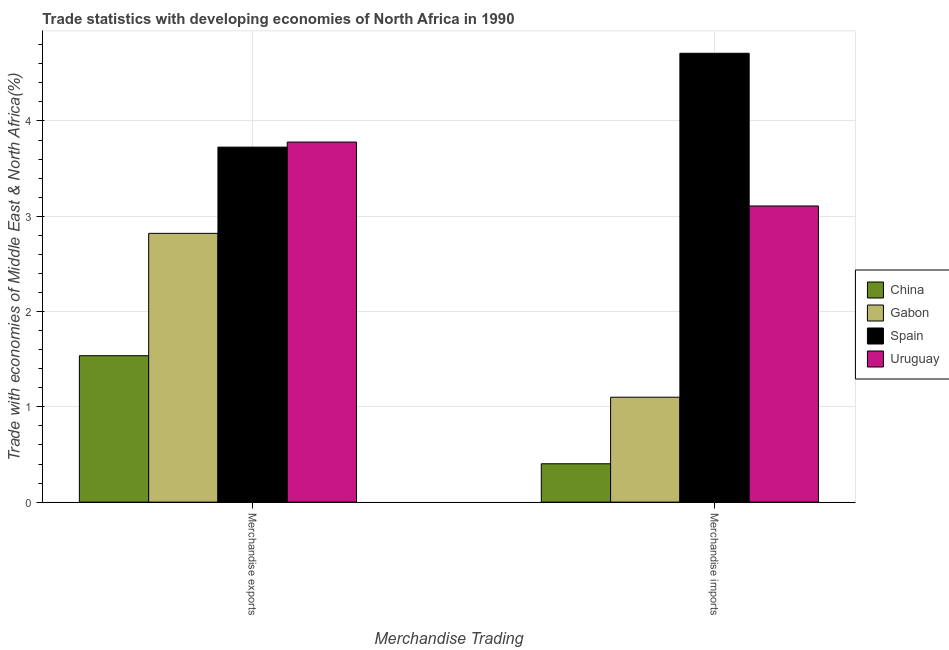How many different coloured bars are there?
Provide a succinct answer. 4. How many groups of bars are there?
Your answer should be very brief. 2. Are the number of bars per tick equal to the number of legend labels?
Keep it short and to the point. Yes. How many bars are there on the 2nd tick from the left?
Provide a succinct answer. 4. How many bars are there on the 2nd tick from the right?
Give a very brief answer. 4. What is the merchandise imports in Spain?
Your answer should be very brief. 4.71. Across all countries, what is the maximum merchandise imports?
Provide a succinct answer. 4.71. Across all countries, what is the minimum merchandise exports?
Make the answer very short. 1.54. In which country was the merchandise exports maximum?
Offer a terse response. Uruguay. In which country was the merchandise imports minimum?
Your response must be concise. China. What is the total merchandise imports in the graph?
Make the answer very short. 9.32. What is the difference between the merchandise exports in China and that in Spain?
Your answer should be compact. -2.19. What is the difference between the merchandise exports in China and the merchandise imports in Spain?
Your answer should be very brief. -3.17. What is the average merchandise imports per country?
Your response must be concise. 2.33. What is the difference between the merchandise imports and merchandise exports in Spain?
Keep it short and to the point. 0.98. What is the ratio of the merchandise imports in Uruguay to that in Gabon?
Your answer should be compact. 2.82. What does the 3rd bar from the right in Merchandise exports represents?
Provide a short and direct response. Gabon. How many bars are there?
Ensure brevity in your answer.  8. Are all the bars in the graph horizontal?
Provide a succinct answer. No. Does the graph contain any zero values?
Give a very brief answer. No. Where does the legend appear in the graph?
Provide a succinct answer. Center right. What is the title of the graph?
Your answer should be very brief. Trade statistics with developing economies of North Africa in 1990. Does "High income: OECD" appear as one of the legend labels in the graph?
Offer a terse response. No. What is the label or title of the X-axis?
Provide a short and direct response. Merchandise Trading. What is the label or title of the Y-axis?
Your response must be concise. Trade with economies of Middle East & North Africa(%). What is the Trade with economies of Middle East & North Africa(%) in China in Merchandise exports?
Your response must be concise. 1.54. What is the Trade with economies of Middle East & North Africa(%) in Gabon in Merchandise exports?
Your answer should be compact. 2.82. What is the Trade with economies of Middle East & North Africa(%) in Spain in Merchandise exports?
Keep it short and to the point. 3.73. What is the Trade with economies of Middle East & North Africa(%) in Uruguay in Merchandise exports?
Ensure brevity in your answer.  3.78. What is the Trade with economies of Middle East & North Africa(%) in China in Merchandise imports?
Your answer should be compact. 0.4. What is the Trade with economies of Middle East & North Africa(%) of Gabon in Merchandise imports?
Offer a terse response. 1.1. What is the Trade with economies of Middle East & North Africa(%) in Spain in Merchandise imports?
Make the answer very short. 4.71. What is the Trade with economies of Middle East & North Africa(%) in Uruguay in Merchandise imports?
Your response must be concise. 3.11. Across all Merchandise Trading, what is the maximum Trade with economies of Middle East & North Africa(%) in China?
Give a very brief answer. 1.54. Across all Merchandise Trading, what is the maximum Trade with economies of Middle East & North Africa(%) of Gabon?
Your answer should be very brief. 2.82. Across all Merchandise Trading, what is the maximum Trade with economies of Middle East & North Africa(%) of Spain?
Make the answer very short. 4.71. Across all Merchandise Trading, what is the maximum Trade with economies of Middle East & North Africa(%) in Uruguay?
Ensure brevity in your answer.  3.78. Across all Merchandise Trading, what is the minimum Trade with economies of Middle East & North Africa(%) of China?
Offer a terse response. 0.4. Across all Merchandise Trading, what is the minimum Trade with economies of Middle East & North Africa(%) of Gabon?
Offer a very short reply. 1.1. Across all Merchandise Trading, what is the minimum Trade with economies of Middle East & North Africa(%) in Spain?
Keep it short and to the point. 3.73. Across all Merchandise Trading, what is the minimum Trade with economies of Middle East & North Africa(%) in Uruguay?
Ensure brevity in your answer.  3.11. What is the total Trade with economies of Middle East & North Africa(%) in China in the graph?
Ensure brevity in your answer.  1.94. What is the total Trade with economies of Middle East & North Africa(%) of Gabon in the graph?
Offer a terse response. 3.92. What is the total Trade with economies of Middle East & North Africa(%) in Spain in the graph?
Offer a very short reply. 8.44. What is the total Trade with economies of Middle East & North Africa(%) of Uruguay in the graph?
Your answer should be very brief. 6.89. What is the difference between the Trade with economies of Middle East & North Africa(%) in China in Merchandise exports and that in Merchandise imports?
Make the answer very short. 1.13. What is the difference between the Trade with economies of Middle East & North Africa(%) in Gabon in Merchandise exports and that in Merchandise imports?
Offer a terse response. 1.72. What is the difference between the Trade with economies of Middle East & North Africa(%) of Spain in Merchandise exports and that in Merchandise imports?
Provide a short and direct response. -0.98. What is the difference between the Trade with economies of Middle East & North Africa(%) in Uruguay in Merchandise exports and that in Merchandise imports?
Give a very brief answer. 0.67. What is the difference between the Trade with economies of Middle East & North Africa(%) in China in Merchandise exports and the Trade with economies of Middle East & North Africa(%) in Gabon in Merchandise imports?
Keep it short and to the point. 0.44. What is the difference between the Trade with economies of Middle East & North Africa(%) in China in Merchandise exports and the Trade with economies of Middle East & North Africa(%) in Spain in Merchandise imports?
Your answer should be compact. -3.17. What is the difference between the Trade with economies of Middle East & North Africa(%) of China in Merchandise exports and the Trade with economies of Middle East & North Africa(%) of Uruguay in Merchandise imports?
Provide a succinct answer. -1.57. What is the difference between the Trade with economies of Middle East & North Africa(%) of Gabon in Merchandise exports and the Trade with economies of Middle East & North Africa(%) of Spain in Merchandise imports?
Your answer should be compact. -1.89. What is the difference between the Trade with economies of Middle East & North Africa(%) of Gabon in Merchandise exports and the Trade with economies of Middle East & North Africa(%) of Uruguay in Merchandise imports?
Offer a very short reply. -0.29. What is the difference between the Trade with economies of Middle East & North Africa(%) of Spain in Merchandise exports and the Trade with economies of Middle East & North Africa(%) of Uruguay in Merchandise imports?
Your answer should be very brief. 0.62. What is the average Trade with economies of Middle East & North Africa(%) in China per Merchandise Trading?
Provide a succinct answer. 0.97. What is the average Trade with economies of Middle East & North Africa(%) of Gabon per Merchandise Trading?
Your answer should be compact. 1.96. What is the average Trade with economies of Middle East & North Africa(%) of Spain per Merchandise Trading?
Make the answer very short. 4.22. What is the average Trade with economies of Middle East & North Africa(%) of Uruguay per Merchandise Trading?
Give a very brief answer. 3.44. What is the difference between the Trade with economies of Middle East & North Africa(%) in China and Trade with economies of Middle East & North Africa(%) in Gabon in Merchandise exports?
Ensure brevity in your answer.  -1.28. What is the difference between the Trade with economies of Middle East & North Africa(%) in China and Trade with economies of Middle East & North Africa(%) in Spain in Merchandise exports?
Provide a short and direct response. -2.19. What is the difference between the Trade with economies of Middle East & North Africa(%) of China and Trade with economies of Middle East & North Africa(%) of Uruguay in Merchandise exports?
Offer a very short reply. -2.24. What is the difference between the Trade with economies of Middle East & North Africa(%) in Gabon and Trade with economies of Middle East & North Africa(%) in Spain in Merchandise exports?
Offer a very short reply. -0.91. What is the difference between the Trade with economies of Middle East & North Africa(%) in Gabon and Trade with economies of Middle East & North Africa(%) in Uruguay in Merchandise exports?
Make the answer very short. -0.96. What is the difference between the Trade with economies of Middle East & North Africa(%) in Spain and Trade with economies of Middle East & North Africa(%) in Uruguay in Merchandise exports?
Give a very brief answer. -0.05. What is the difference between the Trade with economies of Middle East & North Africa(%) in China and Trade with economies of Middle East & North Africa(%) in Gabon in Merchandise imports?
Provide a short and direct response. -0.7. What is the difference between the Trade with economies of Middle East & North Africa(%) of China and Trade with economies of Middle East & North Africa(%) of Spain in Merchandise imports?
Offer a very short reply. -4.31. What is the difference between the Trade with economies of Middle East & North Africa(%) of China and Trade with economies of Middle East & North Africa(%) of Uruguay in Merchandise imports?
Offer a very short reply. -2.71. What is the difference between the Trade with economies of Middle East & North Africa(%) in Gabon and Trade with economies of Middle East & North Africa(%) in Spain in Merchandise imports?
Offer a terse response. -3.61. What is the difference between the Trade with economies of Middle East & North Africa(%) of Gabon and Trade with economies of Middle East & North Africa(%) of Uruguay in Merchandise imports?
Offer a terse response. -2.01. What is the difference between the Trade with economies of Middle East & North Africa(%) of Spain and Trade with economies of Middle East & North Africa(%) of Uruguay in Merchandise imports?
Your answer should be compact. 1.6. What is the ratio of the Trade with economies of Middle East & North Africa(%) in China in Merchandise exports to that in Merchandise imports?
Your answer should be compact. 3.82. What is the ratio of the Trade with economies of Middle East & North Africa(%) of Gabon in Merchandise exports to that in Merchandise imports?
Your response must be concise. 2.56. What is the ratio of the Trade with economies of Middle East & North Africa(%) of Spain in Merchandise exports to that in Merchandise imports?
Your response must be concise. 0.79. What is the ratio of the Trade with economies of Middle East & North Africa(%) of Uruguay in Merchandise exports to that in Merchandise imports?
Keep it short and to the point. 1.22. What is the difference between the highest and the second highest Trade with economies of Middle East & North Africa(%) of China?
Offer a very short reply. 1.13. What is the difference between the highest and the second highest Trade with economies of Middle East & North Africa(%) in Gabon?
Your response must be concise. 1.72. What is the difference between the highest and the second highest Trade with economies of Middle East & North Africa(%) of Spain?
Provide a short and direct response. 0.98. What is the difference between the highest and the second highest Trade with economies of Middle East & North Africa(%) of Uruguay?
Offer a very short reply. 0.67. What is the difference between the highest and the lowest Trade with economies of Middle East & North Africa(%) in China?
Provide a succinct answer. 1.13. What is the difference between the highest and the lowest Trade with economies of Middle East & North Africa(%) of Gabon?
Give a very brief answer. 1.72. What is the difference between the highest and the lowest Trade with economies of Middle East & North Africa(%) of Spain?
Offer a very short reply. 0.98. What is the difference between the highest and the lowest Trade with economies of Middle East & North Africa(%) of Uruguay?
Your response must be concise. 0.67. 